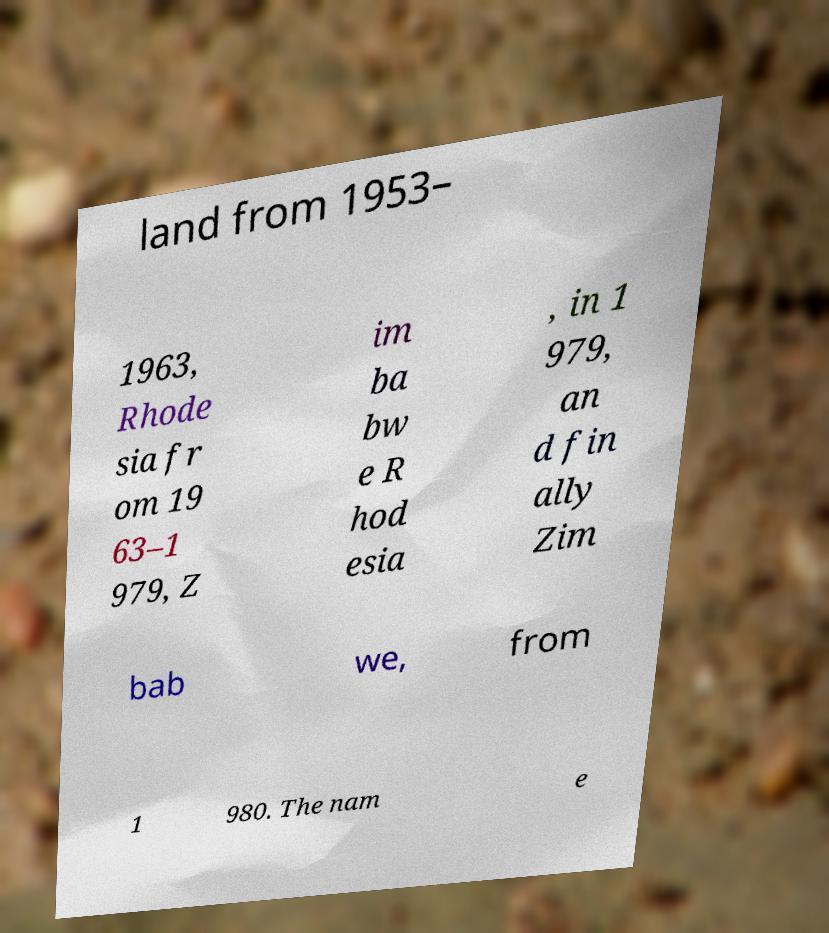Could you extract and type out the text from this image? land from 1953– 1963, Rhode sia fr om 19 63–1 979, Z im ba bw e R hod esia , in 1 979, an d fin ally Zim bab we, from 1 980. The nam e 